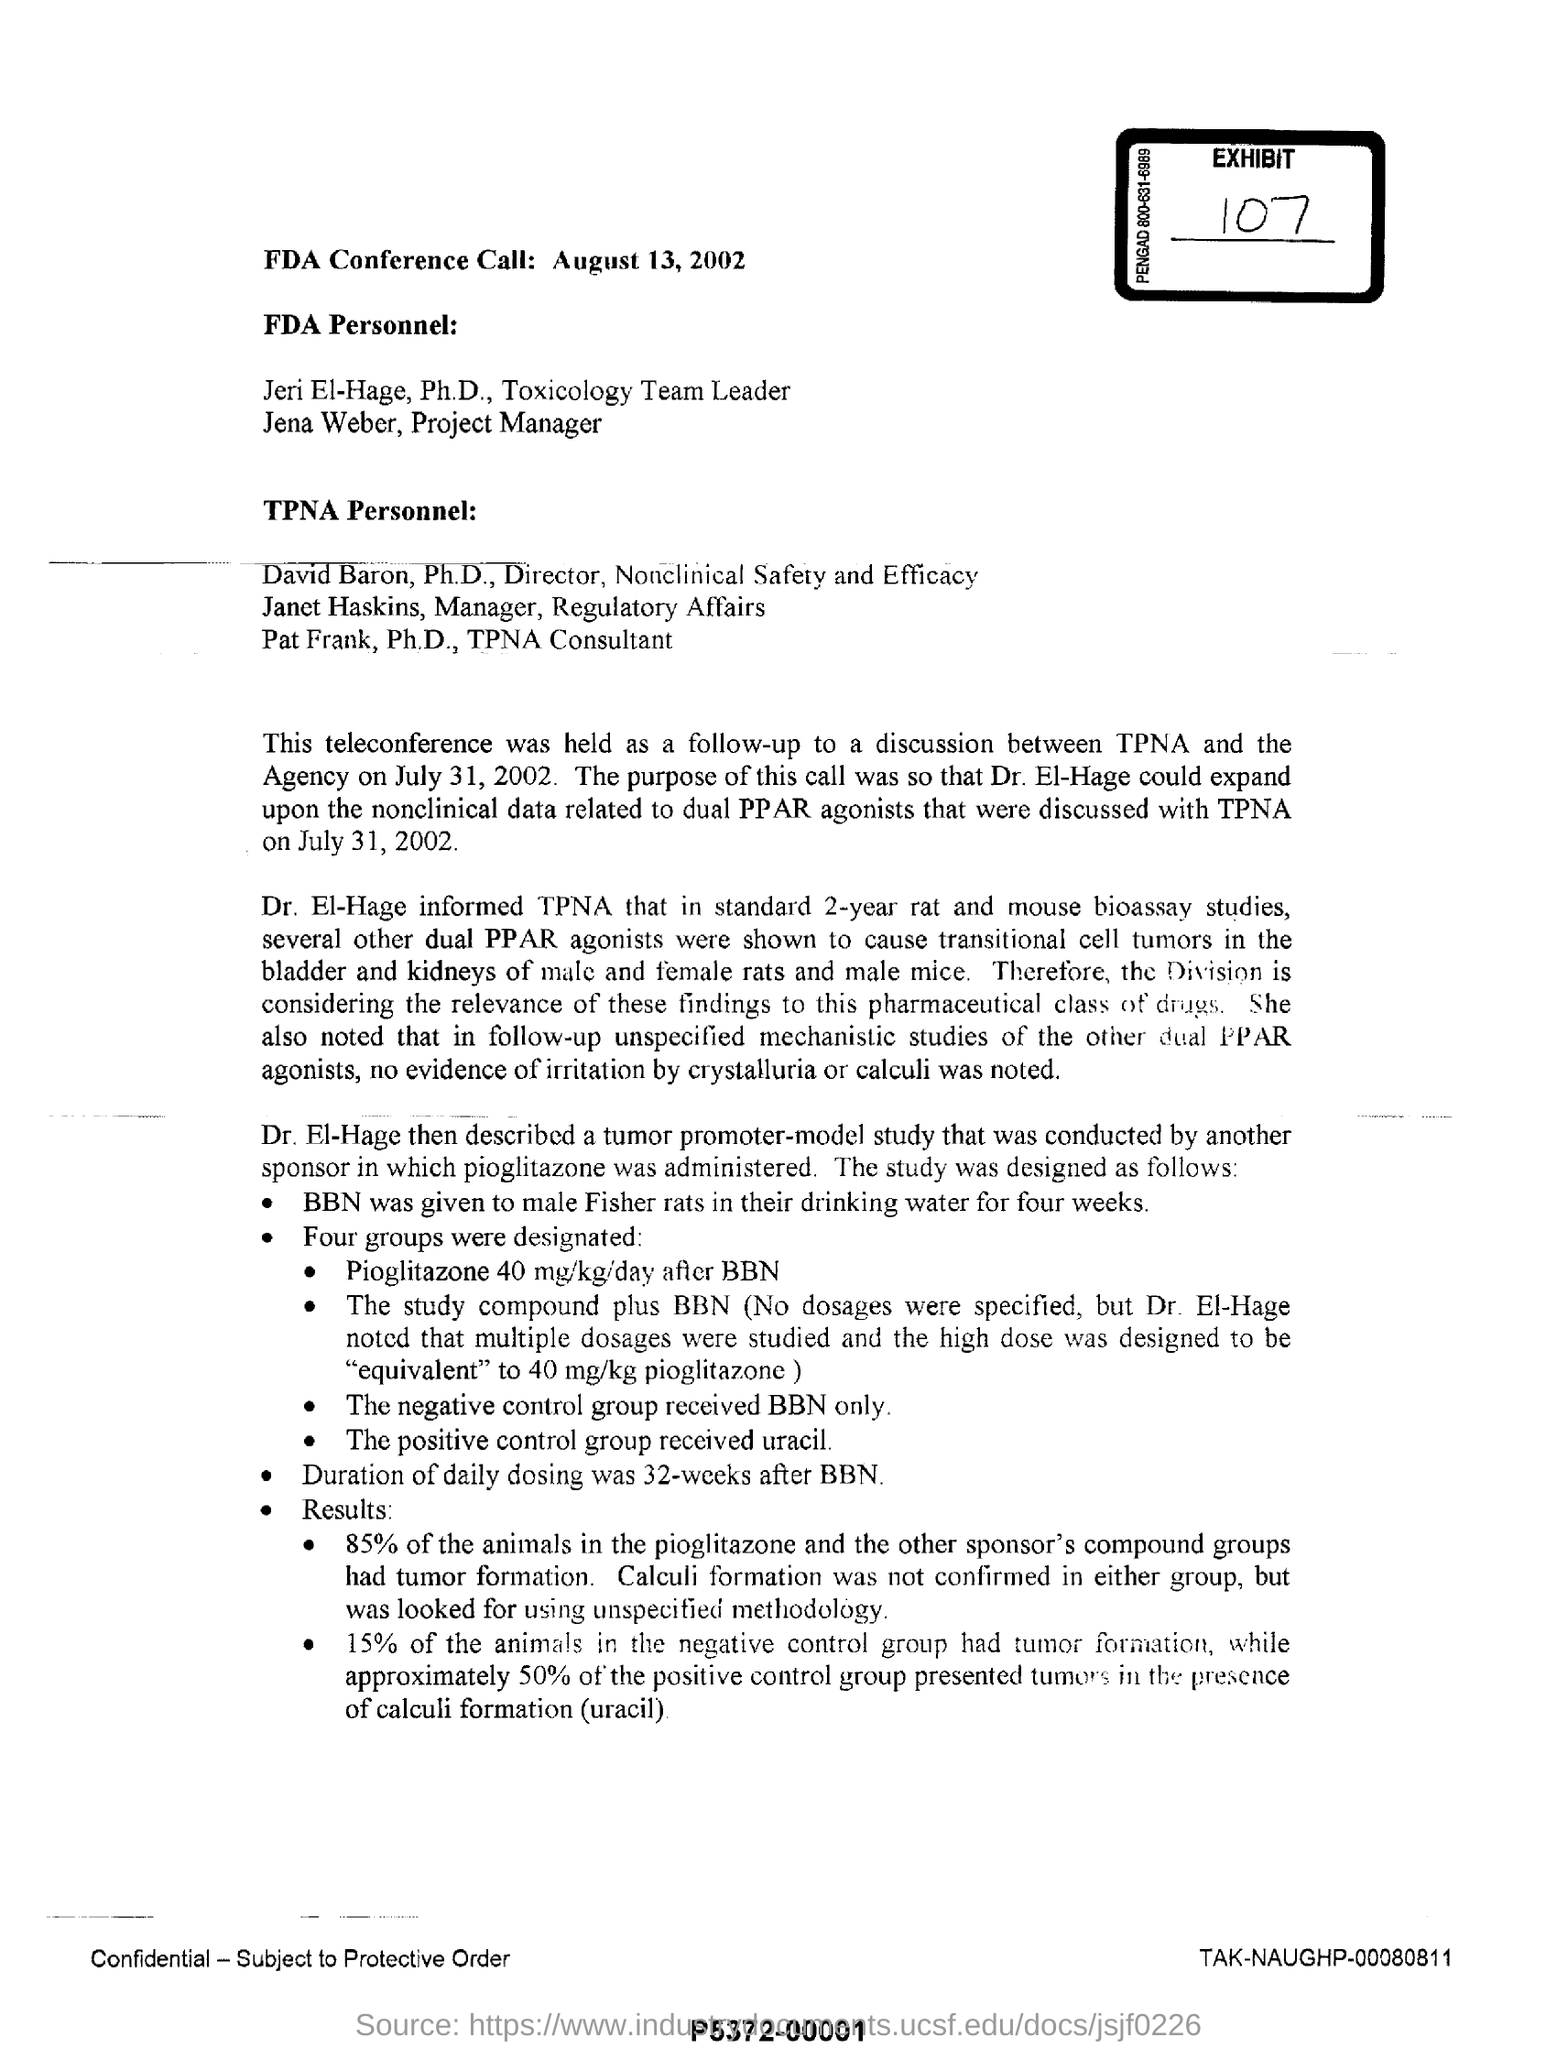What is the duration of daily dosing? The duration of daily dosing in the study referred to in the document was 32 weeks. This study involved Fisher rats and tested the effects of pioglitazone post BBN treatment, comparing tumor formation and calculi development. 